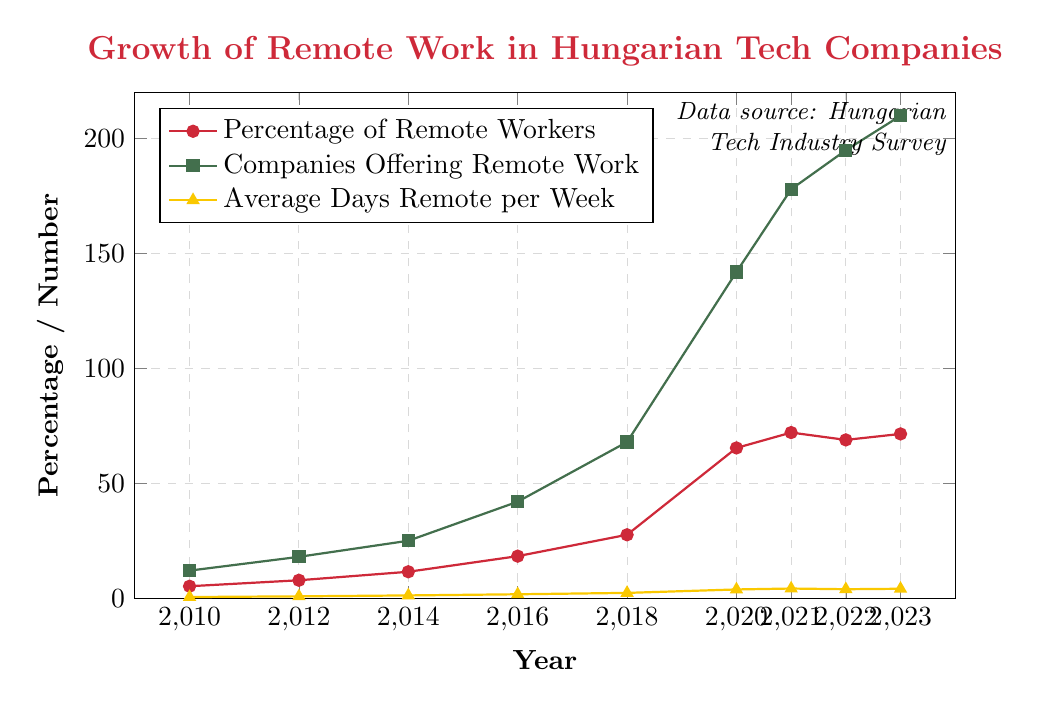What year saw the largest increase in the percentage of remote workers? From the chart, the percentage of remote workers increased dramatically from 27.6% in 2018 to 65.4% in 2020. To find the largest increase, compare these values: 65.4 - 27.6 = 37.8%. No other yearly change is as large.
Answer: 2020 Which year had the highest number of companies offering remote work? From the chart, locate the peak of the green line representing the companies offering remote work. The highest point is in 2023, with 210 companies.
Answer: 2023 How did the average number of remote days per week change between 2016 and 2020? In 2016, the average was 1.7 days, and in 2020 it was 3.8 days. To compute the change, subtract: 3.8 - 1.7 = 2.1 days.
Answer: 2.1 days Which metric showed the most consistent growth throughout the years? By visually inspecting the chart, all metrics generally increased, but the green line representing companies offering remote work shows the most consistent upward trend each year without significant drops.
Answer: Companies Offering Remote Work What is the difference in the percentage of remote workers between 2021 and 2022? From the chart, the percentage in 2021 is 72.1%, and in 2022 it is 68.9%. The difference is calculated as 72.1 - 68.9 = 3.2%.
Answer: 3.2% Comparing 2010 and 2023, how much has the average number of remote days per week increased? In 2010, the average was 0.5 days, and in 2023 it is 4.1 days. The increase can be found by subtracting: 4.1 - 0.5 = 3.6 days.
Answer: 3.6 days Between which two consecutive years did the number of companies offering remote work increase the most? Examine the steepest part of the green line. The steepest increase is from 2018 to 2020, where the number of companies offering remote work rose from 68 to 142. The difference is 142 - 68 = 74 companies.
Answer: 2018 to 2020 What percentage of remote workers was recorded in 2014, and how does it compare to the percentage in 2018? The chart shows the percentage in 2014 is 11.5%, and in 2018 it is 27.6%. To compare, subtract: 27.6 - 11.5 = 16.1%.
Answer: 16.1% increase How does the growth in the average number of remote days per week between 2012 and 2014 compare to the growth between 2022 and 2023? From the chart, growth from 2012 (0.8 days) to 2014 (1.2 days) is 1.2 - 0.8 = 0.4 days. From 2022 (3.9 days) to 2023 (4.1 days) is 4.1 - 3.9 = 0.2 days. Comparing these, the growth from 2012 to 2014 is greater.
Answer: 2012 to 2014 What trend is observed in the percentage of remote workers from 2020 to 2022? From the chart, the percentage of remote workers increased sharply in 2020 from 65.4% and peaked at 72.1% in 2021, then slightly decreased to 68.9% in 2022.
Answer: Increase then slight decrease 